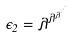Convert formula to latex. <formula><loc_0><loc_0><loc_500><loc_500>\epsilon _ { 2 } = \lambda ^ { \lambda ^ { \lambda ^ { \cdot ^ { \cdot ^ { \cdot } } } } }</formula> 